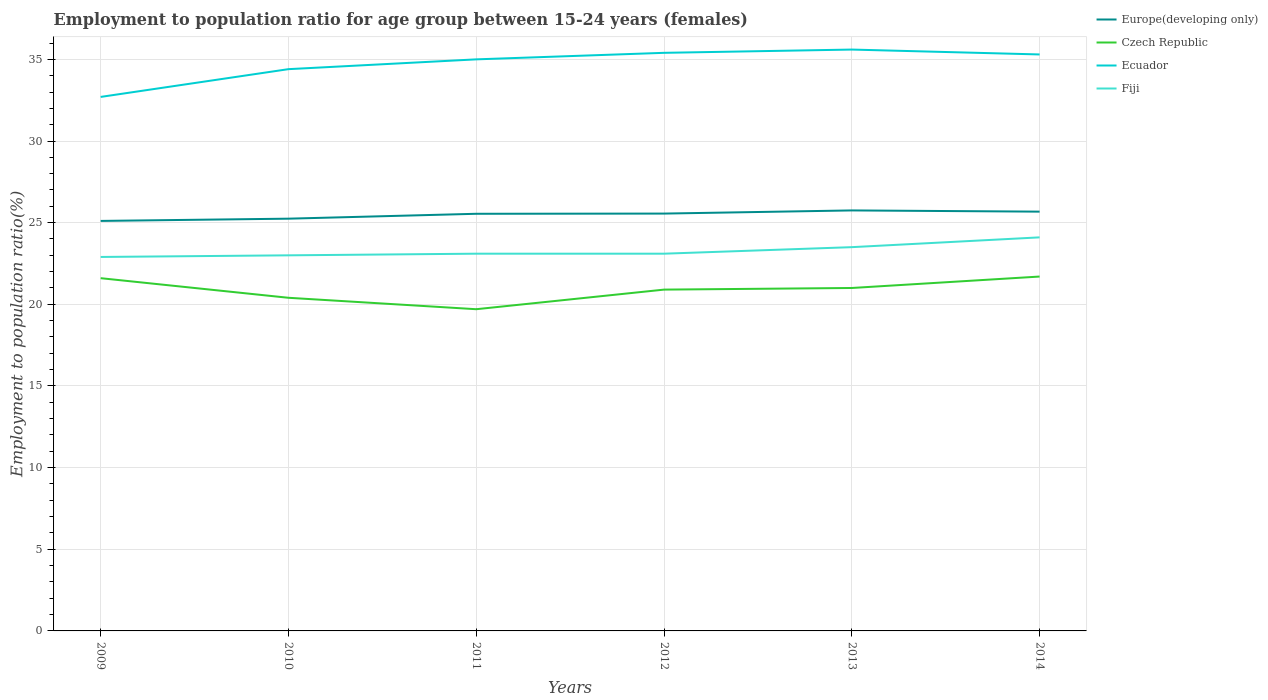Does the line corresponding to Fiji intersect with the line corresponding to Europe(developing only)?
Offer a very short reply. No. Across all years, what is the maximum employment to population ratio in Fiji?
Ensure brevity in your answer.  22.9. What is the total employment to population ratio in Fiji in the graph?
Your response must be concise. -0.6. What is the difference between the highest and the second highest employment to population ratio in Czech Republic?
Your answer should be compact. 2. What is the difference between the highest and the lowest employment to population ratio in Czech Republic?
Provide a short and direct response. 4. Is the employment to population ratio in Czech Republic strictly greater than the employment to population ratio in Fiji over the years?
Provide a succinct answer. Yes. How many lines are there?
Ensure brevity in your answer.  4. What is the difference between two consecutive major ticks on the Y-axis?
Keep it short and to the point. 5. Where does the legend appear in the graph?
Give a very brief answer. Top right. How many legend labels are there?
Make the answer very short. 4. How are the legend labels stacked?
Your answer should be very brief. Vertical. What is the title of the graph?
Ensure brevity in your answer.  Employment to population ratio for age group between 15-24 years (females). What is the label or title of the Y-axis?
Ensure brevity in your answer.  Employment to population ratio(%). What is the Employment to population ratio(%) in Europe(developing only) in 2009?
Provide a short and direct response. 25.11. What is the Employment to population ratio(%) in Czech Republic in 2009?
Offer a terse response. 21.6. What is the Employment to population ratio(%) in Ecuador in 2009?
Offer a very short reply. 32.7. What is the Employment to population ratio(%) in Fiji in 2009?
Provide a succinct answer. 22.9. What is the Employment to population ratio(%) of Europe(developing only) in 2010?
Offer a terse response. 25.24. What is the Employment to population ratio(%) in Czech Republic in 2010?
Offer a very short reply. 20.4. What is the Employment to population ratio(%) in Ecuador in 2010?
Give a very brief answer. 34.4. What is the Employment to population ratio(%) of Europe(developing only) in 2011?
Make the answer very short. 25.54. What is the Employment to population ratio(%) of Czech Republic in 2011?
Make the answer very short. 19.7. What is the Employment to population ratio(%) in Ecuador in 2011?
Keep it short and to the point. 35. What is the Employment to population ratio(%) of Fiji in 2011?
Keep it short and to the point. 23.1. What is the Employment to population ratio(%) in Europe(developing only) in 2012?
Offer a very short reply. 25.56. What is the Employment to population ratio(%) of Czech Republic in 2012?
Ensure brevity in your answer.  20.9. What is the Employment to population ratio(%) of Ecuador in 2012?
Your answer should be compact. 35.4. What is the Employment to population ratio(%) in Fiji in 2012?
Give a very brief answer. 23.1. What is the Employment to population ratio(%) of Europe(developing only) in 2013?
Keep it short and to the point. 25.75. What is the Employment to population ratio(%) in Ecuador in 2013?
Your answer should be compact. 35.6. What is the Employment to population ratio(%) in Fiji in 2013?
Provide a short and direct response. 23.5. What is the Employment to population ratio(%) in Europe(developing only) in 2014?
Provide a succinct answer. 25.67. What is the Employment to population ratio(%) in Czech Republic in 2014?
Your answer should be very brief. 21.7. What is the Employment to population ratio(%) in Ecuador in 2014?
Give a very brief answer. 35.3. What is the Employment to population ratio(%) of Fiji in 2014?
Ensure brevity in your answer.  24.1. Across all years, what is the maximum Employment to population ratio(%) of Europe(developing only)?
Provide a succinct answer. 25.75. Across all years, what is the maximum Employment to population ratio(%) of Czech Republic?
Your response must be concise. 21.7. Across all years, what is the maximum Employment to population ratio(%) in Ecuador?
Give a very brief answer. 35.6. Across all years, what is the maximum Employment to population ratio(%) in Fiji?
Make the answer very short. 24.1. Across all years, what is the minimum Employment to population ratio(%) in Europe(developing only)?
Make the answer very short. 25.11. Across all years, what is the minimum Employment to population ratio(%) of Czech Republic?
Offer a very short reply. 19.7. Across all years, what is the minimum Employment to population ratio(%) of Ecuador?
Provide a short and direct response. 32.7. Across all years, what is the minimum Employment to population ratio(%) of Fiji?
Your answer should be very brief. 22.9. What is the total Employment to population ratio(%) of Europe(developing only) in the graph?
Offer a very short reply. 152.88. What is the total Employment to population ratio(%) in Czech Republic in the graph?
Your response must be concise. 125.3. What is the total Employment to population ratio(%) in Ecuador in the graph?
Provide a succinct answer. 208.4. What is the total Employment to population ratio(%) in Fiji in the graph?
Your answer should be compact. 139.7. What is the difference between the Employment to population ratio(%) of Europe(developing only) in 2009 and that in 2010?
Offer a terse response. -0.14. What is the difference between the Employment to population ratio(%) in Czech Republic in 2009 and that in 2010?
Provide a short and direct response. 1.2. What is the difference between the Employment to population ratio(%) in Ecuador in 2009 and that in 2010?
Your answer should be compact. -1.7. What is the difference between the Employment to population ratio(%) of Fiji in 2009 and that in 2010?
Your response must be concise. -0.1. What is the difference between the Employment to population ratio(%) of Europe(developing only) in 2009 and that in 2011?
Keep it short and to the point. -0.44. What is the difference between the Employment to population ratio(%) in Fiji in 2009 and that in 2011?
Your answer should be very brief. -0.2. What is the difference between the Employment to population ratio(%) of Europe(developing only) in 2009 and that in 2012?
Ensure brevity in your answer.  -0.45. What is the difference between the Employment to population ratio(%) in Fiji in 2009 and that in 2012?
Provide a short and direct response. -0.2. What is the difference between the Employment to population ratio(%) of Europe(developing only) in 2009 and that in 2013?
Provide a short and direct response. -0.64. What is the difference between the Employment to population ratio(%) in Ecuador in 2009 and that in 2013?
Ensure brevity in your answer.  -2.9. What is the difference between the Employment to population ratio(%) of Fiji in 2009 and that in 2013?
Your answer should be compact. -0.6. What is the difference between the Employment to population ratio(%) in Europe(developing only) in 2009 and that in 2014?
Keep it short and to the point. -0.57. What is the difference between the Employment to population ratio(%) of Czech Republic in 2009 and that in 2014?
Offer a terse response. -0.1. What is the difference between the Employment to population ratio(%) of Ecuador in 2009 and that in 2014?
Give a very brief answer. -2.6. What is the difference between the Employment to population ratio(%) of Fiji in 2009 and that in 2014?
Make the answer very short. -1.2. What is the difference between the Employment to population ratio(%) in Europe(developing only) in 2010 and that in 2011?
Offer a terse response. -0.3. What is the difference between the Employment to population ratio(%) of Fiji in 2010 and that in 2011?
Make the answer very short. -0.1. What is the difference between the Employment to population ratio(%) in Europe(developing only) in 2010 and that in 2012?
Your response must be concise. -0.31. What is the difference between the Employment to population ratio(%) of Europe(developing only) in 2010 and that in 2013?
Offer a terse response. -0.51. What is the difference between the Employment to population ratio(%) in Ecuador in 2010 and that in 2013?
Offer a terse response. -1.2. What is the difference between the Employment to population ratio(%) in Europe(developing only) in 2010 and that in 2014?
Your answer should be very brief. -0.43. What is the difference between the Employment to population ratio(%) of Ecuador in 2010 and that in 2014?
Ensure brevity in your answer.  -0.9. What is the difference between the Employment to population ratio(%) in Fiji in 2010 and that in 2014?
Your answer should be compact. -1.1. What is the difference between the Employment to population ratio(%) in Europe(developing only) in 2011 and that in 2012?
Offer a very short reply. -0.01. What is the difference between the Employment to population ratio(%) of Czech Republic in 2011 and that in 2012?
Provide a short and direct response. -1.2. What is the difference between the Employment to population ratio(%) of Fiji in 2011 and that in 2012?
Offer a terse response. 0. What is the difference between the Employment to population ratio(%) in Europe(developing only) in 2011 and that in 2013?
Offer a very short reply. -0.21. What is the difference between the Employment to population ratio(%) in Czech Republic in 2011 and that in 2013?
Give a very brief answer. -1.3. What is the difference between the Employment to population ratio(%) in Fiji in 2011 and that in 2013?
Provide a succinct answer. -0.4. What is the difference between the Employment to population ratio(%) of Europe(developing only) in 2011 and that in 2014?
Your answer should be compact. -0.13. What is the difference between the Employment to population ratio(%) in Czech Republic in 2011 and that in 2014?
Your answer should be compact. -2. What is the difference between the Employment to population ratio(%) of Europe(developing only) in 2012 and that in 2013?
Provide a short and direct response. -0.19. What is the difference between the Employment to population ratio(%) of Europe(developing only) in 2012 and that in 2014?
Provide a succinct answer. -0.12. What is the difference between the Employment to population ratio(%) in Czech Republic in 2012 and that in 2014?
Provide a short and direct response. -0.8. What is the difference between the Employment to population ratio(%) in Europe(developing only) in 2013 and that in 2014?
Provide a short and direct response. 0.07. What is the difference between the Employment to population ratio(%) of Czech Republic in 2013 and that in 2014?
Give a very brief answer. -0.7. What is the difference between the Employment to population ratio(%) in Ecuador in 2013 and that in 2014?
Offer a very short reply. 0.3. What is the difference between the Employment to population ratio(%) in Europe(developing only) in 2009 and the Employment to population ratio(%) in Czech Republic in 2010?
Your response must be concise. 4.71. What is the difference between the Employment to population ratio(%) in Europe(developing only) in 2009 and the Employment to population ratio(%) in Ecuador in 2010?
Your response must be concise. -9.29. What is the difference between the Employment to population ratio(%) in Europe(developing only) in 2009 and the Employment to population ratio(%) in Fiji in 2010?
Ensure brevity in your answer.  2.11. What is the difference between the Employment to population ratio(%) in Europe(developing only) in 2009 and the Employment to population ratio(%) in Czech Republic in 2011?
Provide a succinct answer. 5.41. What is the difference between the Employment to population ratio(%) in Europe(developing only) in 2009 and the Employment to population ratio(%) in Ecuador in 2011?
Provide a succinct answer. -9.89. What is the difference between the Employment to population ratio(%) of Europe(developing only) in 2009 and the Employment to population ratio(%) of Fiji in 2011?
Ensure brevity in your answer.  2.01. What is the difference between the Employment to population ratio(%) in Czech Republic in 2009 and the Employment to population ratio(%) in Fiji in 2011?
Ensure brevity in your answer.  -1.5. What is the difference between the Employment to population ratio(%) of Ecuador in 2009 and the Employment to population ratio(%) of Fiji in 2011?
Make the answer very short. 9.6. What is the difference between the Employment to population ratio(%) in Europe(developing only) in 2009 and the Employment to population ratio(%) in Czech Republic in 2012?
Offer a terse response. 4.21. What is the difference between the Employment to population ratio(%) in Europe(developing only) in 2009 and the Employment to population ratio(%) in Ecuador in 2012?
Keep it short and to the point. -10.29. What is the difference between the Employment to population ratio(%) of Europe(developing only) in 2009 and the Employment to population ratio(%) of Fiji in 2012?
Your answer should be very brief. 2.01. What is the difference between the Employment to population ratio(%) of Ecuador in 2009 and the Employment to population ratio(%) of Fiji in 2012?
Your response must be concise. 9.6. What is the difference between the Employment to population ratio(%) of Europe(developing only) in 2009 and the Employment to population ratio(%) of Czech Republic in 2013?
Your answer should be compact. 4.11. What is the difference between the Employment to population ratio(%) of Europe(developing only) in 2009 and the Employment to population ratio(%) of Ecuador in 2013?
Offer a very short reply. -10.49. What is the difference between the Employment to population ratio(%) of Europe(developing only) in 2009 and the Employment to population ratio(%) of Fiji in 2013?
Your answer should be compact. 1.61. What is the difference between the Employment to population ratio(%) in Czech Republic in 2009 and the Employment to population ratio(%) in Fiji in 2013?
Make the answer very short. -1.9. What is the difference between the Employment to population ratio(%) in Europe(developing only) in 2009 and the Employment to population ratio(%) in Czech Republic in 2014?
Provide a short and direct response. 3.41. What is the difference between the Employment to population ratio(%) of Europe(developing only) in 2009 and the Employment to population ratio(%) of Ecuador in 2014?
Your answer should be compact. -10.19. What is the difference between the Employment to population ratio(%) of Europe(developing only) in 2009 and the Employment to population ratio(%) of Fiji in 2014?
Provide a succinct answer. 1.01. What is the difference between the Employment to population ratio(%) in Czech Republic in 2009 and the Employment to population ratio(%) in Ecuador in 2014?
Ensure brevity in your answer.  -13.7. What is the difference between the Employment to population ratio(%) of Ecuador in 2009 and the Employment to population ratio(%) of Fiji in 2014?
Your answer should be very brief. 8.6. What is the difference between the Employment to population ratio(%) of Europe(developing only) in 2010 and the Employment to population ratio(%) of Czech Republic in 2011?
Provide a succinct answer. 5.54. What is the difference between the Employment to population ratio(%) of Europe(developing only) in 2010 and the Employment to population ratio(%) of Ecuador in 2011?
Offer a very short reply. -9.76. What is the difference between the Employment to population ratio(%) in Europe(developing only) in 2010 and the Employment to population ratio(%) in Fiji in 2011?
Provide a short and direct response. 2.14. What is the difference between the Employment to population ratio(%) of Czech Republic in 2010 and the Employment to population ratio(%) of Ecuador in 2011?
Your answer should be very brief. -14.6. What is the difference between the Employment to population ratio(%) in Czech Republic in 2010 and the Employment to population ratio(%) in Fiji in 2011?
Provide a short and direct response. -2.7. What is the difference between the Employment to population ratio(%) in Europe(developing only) in 2010 and the Employment to population ratio(%) in Czech Republic in 2012?
Your answer should be compact. 4.34. What is the difference between the Employment to population ratio(%) of Europe(developing only) in 2010 and the Employment to population ratio(%) of Ecuador in 2012?
Ensure brevity in your answer.  -10.16. What is the difference between the Employment to population ratio(%) of Europe(developing only) in 2010 and the Employment to population ratio(%) of Fiji in 2012?
Offer a very short reply. 2.14. What is the difference between the Employment to population ratio(%) of Czech Republic in 2010 and the Employment to population ratio(%) of Ecuador in 2012?
Offer a very short reply. -15. What is the difference between the Employment to population ratio(%) in Czech Republic in 2010 and the Employment to population ratio(%) in Fiji in 2012?
Your answer should be very brief. -2.7. What is the difference between the Employment to population ratio(%) of Ecuador in 2010 and the Employment to population ratio(%) of Fiji in 2012?
Offer a terse response. 11.3. What is the difference between the Employment to population ratio(%) in Europe(developing only) in 2010 and the Employment to population ratio(%) in Czech Republic in 2013?
Ensure brevity in your answer.  4.24. What is the difference between the Employment to population ratio(%) in Europe(developing only) in 2010 and the Employment to population ratio(%) in Ecuador in 2013?
Make the answer very short. -10.36. What is the difference between the Employment to population ratio(%) of Europe(developing only) in 2010 and the Employment to population ratio(%) of Fiji in 2013?
Offer a terse response. 1.74. What is the difference between the Employment to population ratio(%) of Czech Republic in 2010 and the Employment to population ratio(%) of Ecuador in 2013?
Ensure brevity in your answer.  -15.2. What is the difference between the Employment to population ratio(%) of Czech Republic in 2010 and the Employment to population ratio(%) of Fiji in 2013?
Provide a succinct answer. -3.1. What is the difference between the Employment to population ratio(%) in Europe(developing only) in 2010 and the Employment to population ratio(%) in Czech Republic in 2014?
Provide a succinct answer. 3.54. What is the difference between the Employment to population ratio(%) of Europe(developing only) in 2010 and the Employment to population ratio(%) of Ecuador in 2014?
Your response must be concise. -10.06. What is the difference between the Employment to population ratio(%) in Europe(developing only) in 2010 and the Employment to population ratio(%) in Fiji in 2014?
Make the answer very short. 1.14. What is the difference between the Employment to population ratio(%) in Czech Republic in 2010 and the Employment to population ratio(%) in Ecuador in 2014?
Your answer should be very brief. -14.9. What is the difference between the Employment to population ratio(%) in Czech Republic in 2010 and the Employment to population ratio(%) in Fiji in 2014?
Make the answer very short. -3.7. What is the difference between the Employment to population ratio(%) of Ecuador in 2010 and the Employment to population ratio(%) of Fiji in 2014?
Provide a succinct answer. 10.3. What is the difference between the Employment to population ratio(%) of Europe(developing only) in 2011 and the Employment to population ratio(%) of Czech Republic in 2012?
Provide a succinct answer. 4.64. What is the difference between the Employment to population ratio(%) in Europe(developing only) in 2011 and the Employment to population ratio(%) in Ecuador in 2012?
Give a very brief answer. -9.86. What is the difference between the Employment to population ratio(%) in Europe(developing only) in 2011 and the Employment to population ratio(%) in Fiji in 2012?
Your response must be concise. 2.44. What is the difference between the Employment to population ratio(%) of Czech Republic in 2011 and the Employment to population ratio(%) of Ecuador in 2012?
Provide a short and direct response. -15.7. What is the difference between the Employment to population ratio(%) in Ecuador in 2011 and the Employment to population ratio(%) in Fiji in 2012?
Ensure brevity in your answer.  11.9. What is the difference between the Employment to population ratio(%) in Europe(developing only) in 2011 and the Employment to population ratio(%) in Czech Republic in 2013?
Your answer should be compact. 4.54. What is the difference between the Employment to population ratio(%) of Europe(developing only) in 2011 and the Employment to population ratio(%) of Ecuador in 2013?
Provide a short and direct response. -10.06. What is the difference between the Employment to population ratio(%) in Europe(developing only) in 2011 and the Employment to population ratio(%) in Fiji in 2013?
Make the answer very short. 2.04. What is the difference between the Employment to population ratio(%) in Czech Republic in 2011 and the Employment to population ratio(%) in Ecuador in 2013?
Your response must be concise. -15.9. What is the difference between the Employment to population ratio(%) of Ecuador in 2011 and the Employment to population ratio(%) of Fiji in 2013?
Provide a short and direct response. 11.5. What is the difference between the Employment to population ratio(%) in Europe(developing only) in 2011 and the Employment to population ratio(%) in Czech Republic in 2014?
Keep it short and to the point. 3.84. What is the difference between the Employment to population ratio(%) of Europe(developing only) in 2011 and the Employment to population ratio(%) of Ecuador in 2014?
Offer a terse response. -9.76. What is the difference between the Employment to population ratio(%) of Europe(developing only) in 2011 and the Employment to population ratio(%) of Fiji in 2014?
Offer a terse response. 1.44. What is the difference between the Employment to population ratio(%) of Czech Republic in 2011 and the Employment to population ratio(%) of Ecuador in 2014?
Offer a terse response. -15.6. What is the difference between the Employment to population ratio(%) of Czech Republic in 2011 and the Employment to population ratio(%) of Fiji in 2014?
Provide a short and direct response. -4.4. What is the difference between the Employment to population ratio(%) in Europe(developing only) in 2012 and the Employment to population ratio(%) in Czech Republic in 2013?
Your answer should be very brief. 4.56. What is the difference between the Employment to population ratio(%) in Europe(developing only) in 2012 and the Employment to population ratio(%) in Ecuador in 2013?
Keep it short and to the point. -10.04. What is the difference between the Employment to population ratio(%) in Europe(developing only) in 2012 and the Employment to population ratio(%) in Fiji in 2013?
Keep it short and to the point. 2.06. What is the difference between the Employment to population ratio(%) in Czech Republic in 2012 and the Employment to population ratio(%) in Ecuador in 2013?
Provide a succinct answer. -14.7. What is the difference between the Employment to population ratio(%) in Czech Republic in 2012 and the Employment to population ratio(%) in Fiji in 2013?
Your answer should be very brief. -2.6. What is the difference between the Employment to population ratio(%) of Ecuador in 2012 and the Employment to population ratio(%) of Fiji in 2013?
Provide a short and direct response. 11.9. What is the difference between the Employment to population ratio(%) of Europe(developing only) in 2012 and the Employment to population ratio(%) of Czech Republic in 2014?
Give a very brief answer. 3.86. What is the difference between the Employment to population ratio(%) of Europe(developing only) in 2012 and the Employment to population ratio(%) of Ecuador in 2014?
Ensure brevity in your answer.  -9.74. What is the difference between the Employment to population ratio(%) of Europe(developing only) in 2012 and the Employment to population ratio(%) of Fiji in 2014?
Offer a terse response. 1.46. What is the difference between the Employment to population ratio(%) in Czech Republic in 2012 and the Employment to population ratio(%) in Ecuador in 2014?
Your answer should be very brief. -14.4. What is the difference between the Employment to population ratio(%) of Europe(developing only) in 2013 and the Employment to population ratio(%) of Czech Republic in 2014?
Provide a succinct answer. 4.05. What is the difference between the Employment to population ratio(%) in Europe(developing only) in 2013 and the Employment to population ratio(%) in Ecuador in 2014?
Keep it short and to the point. -9.55. What is the difference between the Employment to population ratio(%) of Europe(developing only) in 2013 and the Employment to population ratio(%) of Fiji in 2014?
Your answer should be very brief. 1.65. What is the difference between the Employment to population ratio(%) of Czech Republic in 2013 and the Employment to population ratio(%) of Ecuador in 2014?
Your response must be concise. -14.3. What is the average Employment to population ratio(%) of Europe(developing only) per year?
Your response must be concise. 25.48. What is the average Employment to population ratio(%) of Czech Republic per year?
Offer a terse response. 20.88. What is the average Employment to population ratio(%) of Ecuador per year?
Keep it short and to the point. 34.73. What is the average Employment to population ratio(%) in Fiji per year?
Your answer should be compact. 23.28. In the year 2009, what is the difference between the Employment to population ratio(%) of Europe(developing only) and Employment to population ratio(%) of Czech Republic?
Keep it short and to the point. 3.51. In the year 2009, what is the difference between the Employment to population ratio(%) in Europe(developing only) and Employment to population ratio(%) in Ecuador?
Your answer should be very brief. -7.59. In the year 2009, what is the difference between the Employment to population ratio(%) in Europe(developing only) and Employment to population ratio(%) in Fiji?
Make the answer very short. 2.21. In the year 2009, what is the difference between the Employment to population ratio(%) of Czech Republic and Employment to population ratio(%) of Fiji?
Keep it short and to the point. -1.3. In the year 2010, what is the difference between the Employment to population ratio(%) of Europe(developing only) and Employment to population ratio(%) of Czech Republic?
Your response must be concise. 4.84. In the year 2010, what is the difference between the Employment to population ratio(%) in Europe(developing only) and Employment to population ratio(%) in Ecuador?
Make the answer very short. -9.16. In the year 2010, what is the difference between the Employment to population ratio(%) in Europe(developing only) and Employment to population ratio(%) in Fiji?
Make the answer very short. 2.24. In the year 2010, what is the difference between the Employment to population ratio(%) of Czech Republic and Employment to population ratio(%) of Ecuador?
Keep it short and to the point. -14. In the year 2011, what is the difference between the Employment to population ratio(%) of Europe(developing only) and Employment to population ratio(%) of Czech Republic?
Ensure brevity in your answer.  5.84. In the year 2011, what is the difference between the Employment to population ratio(%) of Europe(developing only) and Employment to population ratio(%) of Ecuador?
Your answer should be very brief. -9.46. In the year 2011, what is the difference between the Employment to population ratio(%) in Europe(developing only) and Employment to population ratio(%) in Fiji?
Give a very brief answer. 2.44. In the year 2011, what is the difference between the Employment to population ratio(%) of Czech Republic and Employment to population ratio(%) of Ecuador?
Your response must be concise. -15.3. In the year 2011, what is the difference between the Employment to population ratio(%) of Czech Republic and Employment to population ratio(%) of Fiji?
Give a very brief answer. -3.4. In the year 2011, what is the difference between the Employment to population ratio(%) of Ecuador and Employment to population ratio(%) of Fiji?
Your answer should be compact. 11.9. In the year 2012, what is the difference between the Employment to population ratio(%) in Europe(developing only) and Employment to population ratio(%) in Czech Republic?
Your response must be concise. 4.66. In the year 2012, what is the difference between the Employment to population ratio(%) of Europe(developing only) and Employment to population ratio(%) of Ecuador?
Make the answer very short. -9.84. In the year 2012, what is the difference between the Employment to population ratio(%) of Europe(developing only) and Employment to population ratio(%) of Fiji?
Provide a short and direct response. 2.46. In the year 2013, what is the difference between the Employment to population ratio(%) in Europe(developing only) and Employment to population ratio(%) in Czech Republic?
Keep it short and to the point. 4.75. In the year 2013, what is the difference between the Employment to population ratio(%) of Europe(developing only) and Employment to population ratio(%) of Ecuador?
Keep it short and to the point. -9.85. In the year 2013, what is the difference between the Employment to population ratio(%) in Europe(developing only) and Employment to population ratio(%) in Fiji?
Offer a very short reply. 2.25. In the year 2013, what is the difference between the Employment to population ratio(%) of Czech Republic and Employment to population ratio(%) of Ecuador?
Ensure brevity in your answer.  -14.6. In the year 2014, what is the difference between the Employment to population ratio(%) of Europe(developing only) and Employment to population ratio(%) of Czech Republic?
Keep it short and to the point. 3.97. In the year 2014, what is the difference between the Employment to population ratio(%) of Europe(developing only) and Employment to population ratio(%) of Ecuador?
Offer a very short reply. -9.63. In the year 2014, what is the difference between the Employment to population ratio(%) of Europe(developing only) and Employment to population ratio(%) of Fiji?
Ensure brevity in your answer.  1.57. What is the ratio of the Employment to population ratio(%) in Europe(developing only) in 2009 to that in 2010?
Ensure brevity in your answer.  0.99. What is the ratio of the Employment to population ratio(%) of Czech Republic in 2009 to that in 2010?
Ensure brevity in your answer.  1.06. What is the ratio of the Employment to population ratio(%) in Ecuador in 2009 to that in 2010?
Make the answer very short. 0.95. What is the ratio of the Employment to population ratio(%) of Fiji in 2009 to that in 2010?
Your answer should be compact. 1. What is the ratio of the Employment to population ratio(%) in Europe(developing only) in 2009 to that in 2011?
Your answer should be very brief. 0.98. What is the ratio of the Employment to population ratio(%) in Czech Republic in 2009 to that in 2011?
Your answer should be very brief. 1.1. What is the ratio of the Employment to population ratio(%) in Ecuador in 2009 to that in 2011?
Your answer should be very brief. 0.93. What is the ratio of the Employment to population ratio(%) of Europe(developing only) in 2009 to that in 2012?
Make the answer very short. 0.98. What is the ratio of the Employment to population ratio(%) in Czech Republic in 2009 to that in 2012?
Ensure brevity in your answer.  1.03. What is the ratio of the Employment to population ratio(%) of Ecuador in 2009 to that in 2012?
Your response must be concise. 0.92. What is the ratio of the Employment to population ratio(%) of Fiji in 2009 to that in 2012?
Offer a very short reply. 0.99. What is the ratio of the Employment to population ratio(%) in Europe(developing only) in 2009 to that in 2013?
Offer a very short reply. 0.97. What is the ratio of the Employment to population ratio(%) of Czech Republic in 2009 to that in 2013?
Your answer should be compact. 1.03. What is the ratio of the Employment to population ratio(%) of Ecuador in 2009 to that in 2013?
Your answer should be very brief. 0.92. What is the ratio of the Employment to population ratio(%) in Fiji in 2009 to that in 2013?
Your answer should be compact. 0.97. What is the ratio of the Employment to population ratio(%) in Europe(developing only) in 2009 to that in 2014?
Provide a short and direct response. 0.98. What is the ratio of the Employment to population ratio(%) in Czech Republic in 2009 to that in 2014?
Make the answer very short. 1. What is the ratio of the Employment to population ratio(%) of Ecuador in 2009 to that in 2014?
Provide a short and direct response. 0.93. What is the ratio of the Employment to population ratio(%) of Fiji in 2009 to that in 2014?
Provide a succinct answer. 0.95. What is the ratio of the Employment to population ratio(%) of Europe(developing only) in 2010 to that in 2011?
Your response must be concise. 0.99. What is the ratio of the Employment to population ratio(%) of Czech Republic in 2010 to that in 2011?
Your answer should be very brief. 1.04. What is the ratio of the Employment to population ratio(%) of Ecuador in 2010 to that in 2011?
Provide a succinct answer. 0.98. What is the ratio of the Employment to population ratio(%) of Czech Republic in 2010 to that in 2012?
Give a very brief answer. 0.98. What is the ratio of the Employment to population ratio(%) of Ecuador in 2010 to that in 2012?
Give a very brief answer. 0.97. What is the ratio of the Employment to population ratio(%) of Fiji in 2010 to that in 2012?
Keep it short and to the point. 1. What is the ratio of the Employment to population ratio(%) in Europe(developing only) in 2010 to that in 2013?
Keep it short and to the point. 0.98. What is the ratio of the Employment to population ratio(%) of Czech Republic in 2010 to that in 2013?
Give a very brief answer. 0.97. What is the ratio of the Employment to population ratio(%) of Ecuador in 2010 to that in 2013?
Keep it short and to the point. 0.97. What is the ratio of the Employment to population ratio(%) in Fiji in 2010 to that in 2013?
Ensure brevity in your answer.  0.98. What is the ratio of the Employment to population ratio(%) of Europe(developing only) in 2010 to that in 2014?
Your answer should be compact. 0.98. What is the ratio of the Employment to population ratio(%) of Czech Republic in 2010 to that in 2014?
Keep it short and to the point. 0.94. What is the ratio of the Employment to population ratio(%) of Ecuador in 2010 to that in 2014?
Offer a terse response. 0.97. What is the ratio of the Employment to population ratio(%) in Fiji in 2010 to that in 2014?
Your answer should be very brief. 0.95. What is the ratio of the Employment to population ratio(%) in Czech Republic in 2011 to that in 2012?
Provide a short and direct response. 0.94. What is the ratio of the Employment to population ratio(%) of Ecuador in 2011 to that in 2012?
Offer a very short reply. 0.99. What is the ratio of the Employment to population ratio(%) in Fiji in 2011 to that in 2012?
Provide a succinct answer. 1. What is the ratio of the Employment to population ratio(%) in Czech Republic in 2011 to that in 2013?
Keep it short and to the point. 0.94. What is the ratio of the Employment to population ratio(%) in Ecuador in 2011 to that in 2013?
Ensure brevity in your answer.  0.98. What is the ratio of the Employment to population ratio(%) of Fiji in 2011 to that in 2013?
Offer a very short reply. 0.98. What is the ratio of the Employment to population ratio(%) in Europe(developing only) in 2011 to that in 2014?
Ensure brevity in your answer.  0.99. What is the ratio of the Employment to population ratio(%) in Czech Republic in 2011 to that in 2014?
Give a very brief answer. 0.91. What is the ratio of the Employment to population ratio(%) in Fiji in 2011 to that in 2014?
Make the answer very short. 0.96. What is the ratio of the Employment to population ratio(%) in Fiji in 2012 to that in 2013?
Provide a short and direct response. 0.98. What is the ratio of the Employment to population ratio(%) of Europe(developing only) in 2012 to that in 2014?
Keep it short and to the point. 1. What is the ratio of the Employment to population ratio(%) of Czech Republic in 2012 to that in 2014?
Offer a terse response. 0.96. What is the ratio of the Employment to population ratio(%) of Ecuador in 2012 to that in 2014?
Provide a succinct answer. 1. What is the ratio of the Employment to population ratio(%) in Fiji in 2012 to that in 2014?
Your answer should be very brief. 0.96. What is the ratio of the Employment to population ratio(%) in Europe(developing only) in 2013 to that in 2014?
Ensure brevity in your answer.  1. What is the ratio of the Employment to population ratio(%) of Ecuador in 2013 to that in 2014?
Provide a short and direct response. 1.01. What is the ratio of the Employment to population ratio(%) of Fiji in 2013 to that in 2014?
Give a very brief answer. 0.98. What is the difference between the highest and the second highest Employment to population ratio(%) in Europe(developing only)?
Offer a very short reply. 0.07. What is the difference between the highest and the second highest Employment to population ratio(%) in Fiji?
Make the answer very short. 0.6. What is the difference between the highest and the lowest Employment to population ratio(%) in Europe(developing only)?
Provide a short and direct response. 0.64. What is the difference between the highest and the lowest Employment to population ratio(%) of Czech Republic?
Offer a very short reply. 2. What is the difference between the highest and the lowest Employment to population ratio(%) in Ecuador?
Your answer should be compact. 2.9. What is the difference between the highest and the lowest Employment to population ratio(%) of Fiji?
Make the answer very short. 1.2. 